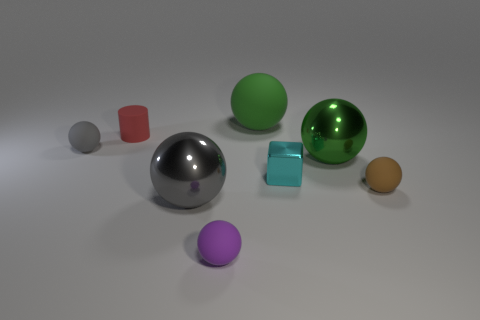There is a brown ball that is the same size as the purple object; what is its material? While the image does not provide definitive information on material properties, the brown ball may likely be made of a matte substance such as clay or plastic based on its lack of reflective surface compared to some other objects in the scene. 